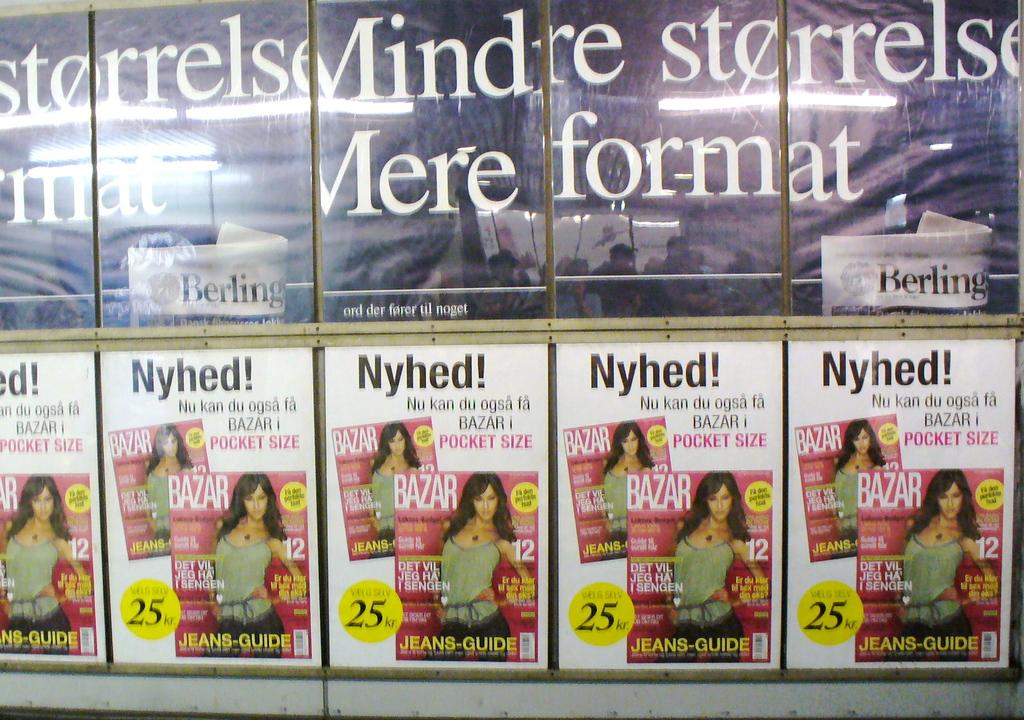What is the name of the magazine?
Make the answer very short. Bazar. 